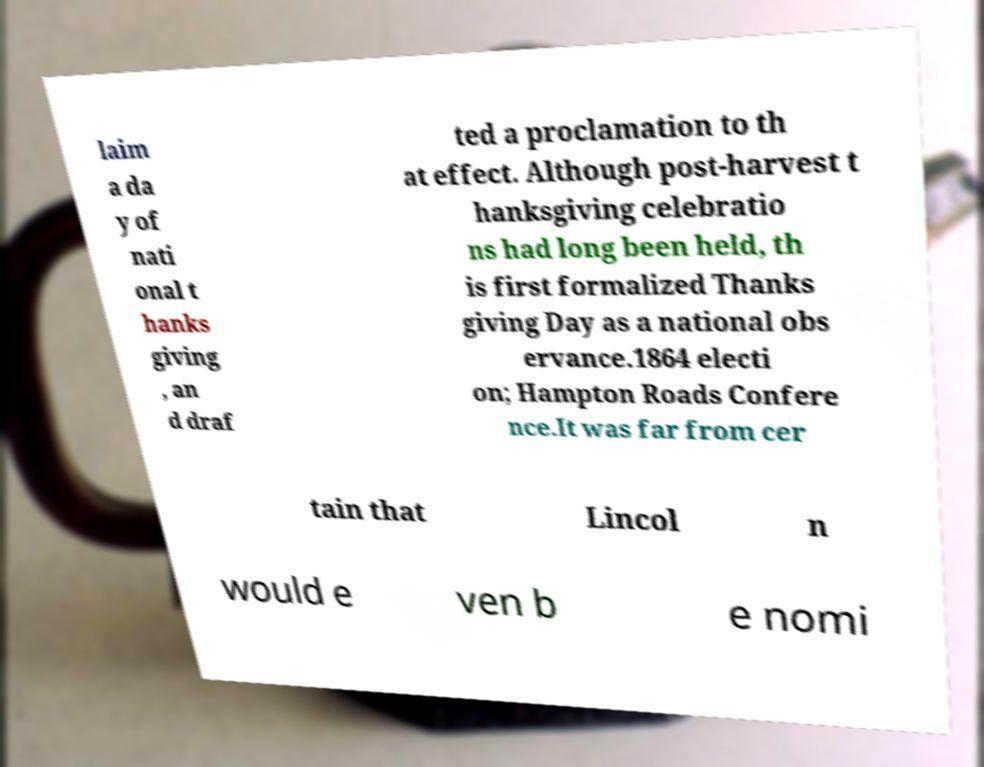Please identify and transcribe the text found in this image. laim a da y of nati onal t hanks giving , an d draf ted a proclamation to th at effect. Although post-harvest t hanksgiving celebratio ns had long been held, th is first formalized Thanks giving Day as a national obs ervance.1864 electi on; Hampton Roads Confere nce.It was far from cer tain that Lincol n would e ven b e nomi 